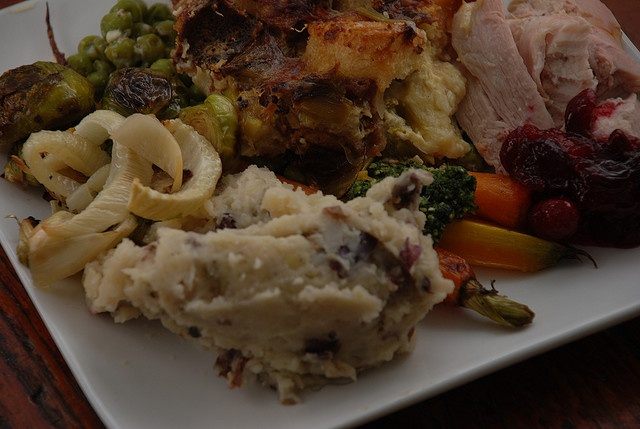Describe the objects in this image and their specific colors. I can see broccoli in black, darkgreen, maroon, and gray tones, carrot in black, maroon, olive, and gray tones, carrot in black and maroon tones, and carrot in black, maroon, and gray tones in this image. 